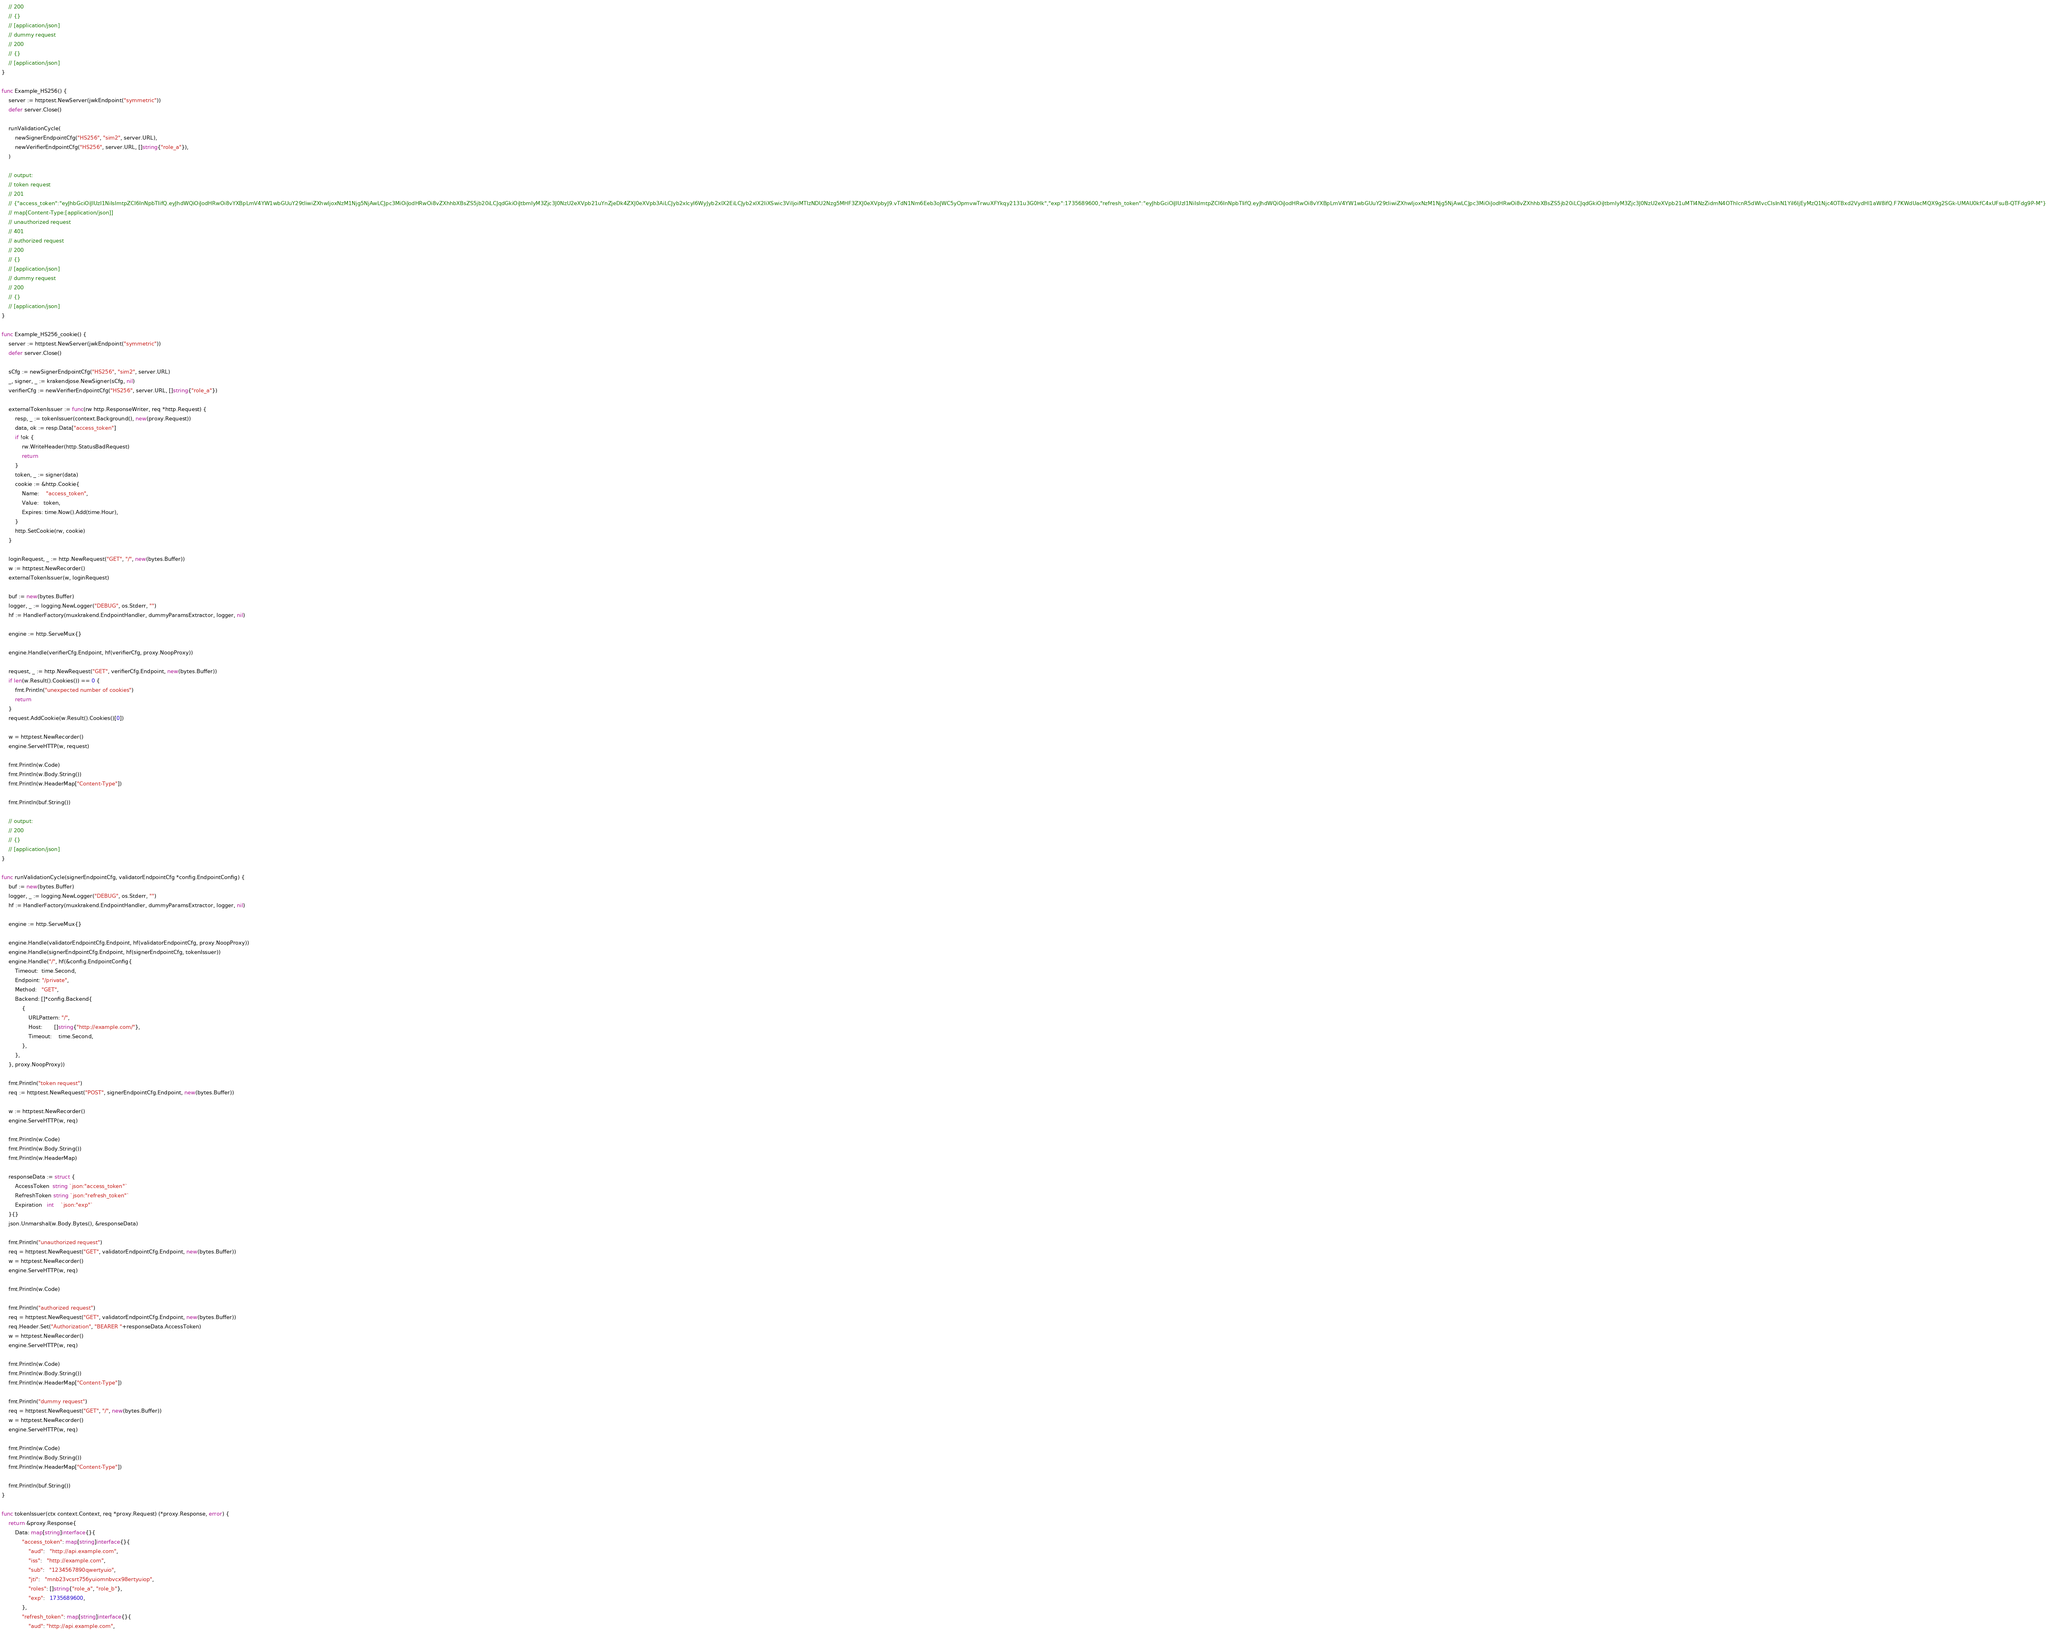<code> <loc_0><loc_0><loc_500><loc_500><_Go_>	// 200
	// {}
	// [application/json]
	// dummy request
	// 200
	// {}
	// [application/json]
}

func Example_HS256() {
	server := httptest.NewServer(jwkEndpoint("symmetric"))
	defer server.Close()

	runValidationCycle(
		newSignerEndpointCfg("HS256", "sim2", server.URL),
		newVerifierEndpointCfg("HS256", server.URL, []string{"role_a"}),
	)

	// output:
	// token request
	// 201
	// {"access_token":"eyJhbGciOiJIUzI1NiIsImtpZCI6InNpbTIifQ.eyJhdWQiOiJodHRwOi8vYXBpLmV4YW1wbGUuY29tIiwiZXhwIjoxNzM1Njg5NjAwLCJpc3MiOiJodHRwOi8vZXhhbXBsZS5jb20iLCJqdGkiOiJtbmIyM3Zjc3J0NzU2eXVpb21uYnZjeDk4ZXJ0eXVpb3AiLCJyb2xlcyI6WyJyb2xlX2EiLCJyb2xlX2IiXSwic3ViIjoiMTIzNDU2Nzg5MHF3ZXJ0eXVpbyJ9.vTdN1Nm6Eeb3oJWC5yOpmvwTrwuXFYkqy2131u3G0Hk","exp":1735689600,"refresh_token":"eyJhbGciOiJIUzI1NiIsImtpZCI6InNpbTIifQ.eyJhdWQiOiJodHRwOi8vYXBpLmV4YW1wbGUuY29tIiwiZXhwIjoxNzM1Njg5NjAwLCJpc3MiOiJodHRwOi8vZXhhbXBsZS5jb20iLCJqdGkiOiJtbmIyM3Zjc3J0NzU2eXVpb21uMTI4NzZidmN4OThlcnR5dWlvcCIsInN1YiI6IjEyMzQ1Njc4OTBxd2VydHl1aW8ifQ.F7KWdUacMQX9g2SGk-UMAU0kfC4xUFsuB-QTFdg9P-M"}
	// map[Content-Type:[application/json]]
	// unauthorized request
	// 401
	// authorized request
	// 200
	// {}
	// [application/json]
	// dummy request
	// 200
	// {}
	// [application/json]
}

func Example_HS256_cookie() {
	server := httptest.NewServer(jwkEndpoint("symmetric"))
	defer server.Close()

	sCfg := newSignerEndpointCfg("HS256", "sim2", server.URL)
	_, signer, _ := krakendjose.NewSigner(sCfg, nil)
	verifierCfg := newVerifierEndpointCfg("HS256", server.URL, []string{"role_a"})

	externalTokenIssuer := func(rw http.ResponseWriter, req *http.Request) {
		resp, _ := tokenIssuer(context.Background(), new(proxy.Request))
		data, ok := resp.Data["access_token"]
		if !ok {
			rw.WriteHeader(http.StatusBadRequest)
			return
		}
		token, _ := signer(data)
		cookie := &http.Cookie{
			Name:    "access_token",
			Value:   token,
			Expires: time.Now().Add(time.Hour),
		}
		http.SetCookie(rw, cookie)
	}

	loginRequest, _ := http.NewRequest("GET", "/", new(bytes.Buffer))
	w := httptest.NewRecorder()
	externalTokenIssuer(w, loginRequest)

	buf := new(bytes.Buffer)
	logger, _ := logging.NewLogger("DEBUG", os.Stderr, "")
	hf := HandlerFactory(muxkrakend.EndpointHandler, dummyParamsExtractor, logger, nil)

	engine := http.ServeMux{}

	engine.Handle(verifierCfg.Endpoint, hf(verifierCfg, proxy.NoopProxy))

	request, _ := http.NewRequest("GET", verifierCfg.Endpoint, new(bytes.Buffer))
	if len(w.Result().Cookies()) == 0 {
		fmt.Println("unexpected number of cookies")
		return
	}
	request.AddCookie(w.Result().Cookies()[0])

	w = httptest.NewRecorder()
	engine.ServeHTTP(w, request)

	fmt.Println(w.Code)
	fmt.Println(w.Body.String())
	fmt.Println(w.HeaderMap["Content-Type"])

	fmt.Println(buf.String())

	// output:
	// 200
	// {}
	// [application/json]
}

func runValidationCycle(signerEndpointCfg, validatorEndpointCfg *config.EndpointConfig) {
	buf := new(bytes.Buffer)
	logger, _ := logging.NewLogger("DEBUG", os.Stderr, "")
	hf := HandlerFactory(muxkrakend.EndpointHandler, dummyParamsExtractor, logger, nil)

	engine := http.ServeMux{}

	engine.Handle(validatorEndpointCfg.Endpoint, hf(validatorEndpointCfg, proxy.NoopProxy))
	engine.Handle(signerEndpointCfg.Endpoint, hf(signerEndpointCfg, tokenIssuer))
	engine.Handle("/", hf(&config.EndpointConfig{
		Timeout:  time.Second,
		Endpoint: "/private",
		Method:   "GET",
		Backend: []*config.Backend{
			{
				URLPattern: "/",
				Host:       []string{"http://example.com/"},
				Timeout:    time.Second,
			},
		},
	}, proxy.NoopProxy))

	fmt.Println("token request")
	req := httptest.NewRequest("POST", signerEndpointCfg.Endpoint, new(bytes.Buffer))

	w := httptest.NewRecorder()
	engine.ServeHTTP(w, req)

	fmt.Println(w.Code)
	fmt.Println(w.Body.String())
	fmt.Println(w.HeaderMap)

	responseData := struct {
		AccessToken  string `json:"access_token"`
		RefreshToken string `json:"refresh_token"`
		Expiration   int    `json:"exp"`
	}{}
	json.Unmarshal(w.Body.Bytes(), &responseData)

	fmt.Println("unauthorized request")
	req = httptest.NewRequest("GET", validatorEndpointCfg.Endpoint, new(bytes.Buffer))
	w = httptest.NewRecorder()
	engine.ServeHTTP(w, req)

	fmt.Println(w.Code)

	fmt.Println("authorized request")
	req = httptest.NewRequest("GET", validatorEndpointCfg.Endpoint, new(bytes.Buffer))
	req.Header.Set("Authorization", "BEARER "+responseData.AccessToken)
	w = httptest.NewRecorder()
	engine.ServeHTTP(w, req)

	fmt.Println(w.Code)
	fmt.Println(w.Body.String())
	fmt.Println(w.HeaderMap["Content-Type"])

	fmt.Println("dummy request")
	req = httptest.NewRequest("GET", "/", new(bytes.Buffer))
	w = httptest.NewRecorder()
	engine.ServeHTTP(w, req)

	fmt.Println(w.Code)
	fmt.Println(w.Body.String())
	fmt.Println(w.HeaderMap["Content-Type"])

	fmt.Println(buf.String())
}

func tokenIssuer(ctx context.Context, req *proxy.Request) (*proxy.Response, error) {
	return &proxy.Response{
		Data: map[string]interface{}{
			"access_token": map[string]interface{}{
				"aud":   "http://api.example.com",
				"iss":   "http://example.com",
				"sub":   "1234567890qwertyuio",
				"jti":   "mnb23vcsrt756yuiomnbvcx98ertyuiop",
				"roles": []string{"role_a", "role_b"},
				"exp":   1735689600,
			},
			"refresh_token": map[string]interface{}{
				"aud": "http://api.example.com",</code> 